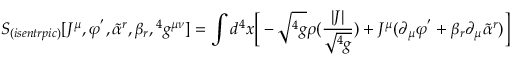<formula> <loc_0><loc_0><loc_500><loc_500>S _ { ( i s e n t r p i c ) } [ J ^ { \mu } , \varphi ^ { ^ { \prime } } , { \tilde { \alpha } } ^ { r } , \beta _ { r } ^ { 4 } g ^ { \mu \nu } ] = \int d ^ { 4 } x \left [ - \sqrt ^ { 4 } g } \rho ( { \frac { | J | } { \sqrt ^ { 4 } g } } } ) + J ^ { \mu } ( \partial _ { \mu } \varphi ^ { ^ { \prime } } + \beta _ { r } \partial _ { \mu } { \tilde { \alpha } } ^ { r } ) \right ]</formula> 